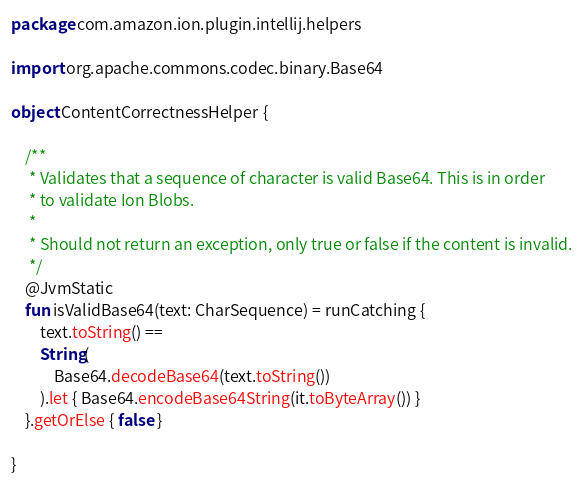Convert code to text. <code><loc_0><loc_0><loc_500><loc_500><_Kotlin_>package com.amazon.ion.plugin.intellij.helpers

import org.apache.commons.codec.binary.Base64

object ContentCorrectnessHelper {

    /**
     * Validates that a sequence of character is valid Base64. This is in order
     * to validate Ion Blobs.
     *
     * Should not return an exception, only true or false if the content is invalid.
     */
    @JvmStatic
    fun isValidBase64(text: CharSequence) = runCatching {
        text.toString() ==
        String(
            Base64.decodeBase64(text.toString())
        ).let { Base64.encodeBase64String(it.toByteArray()) }
    }.getOrElse { false }

}
</code> 